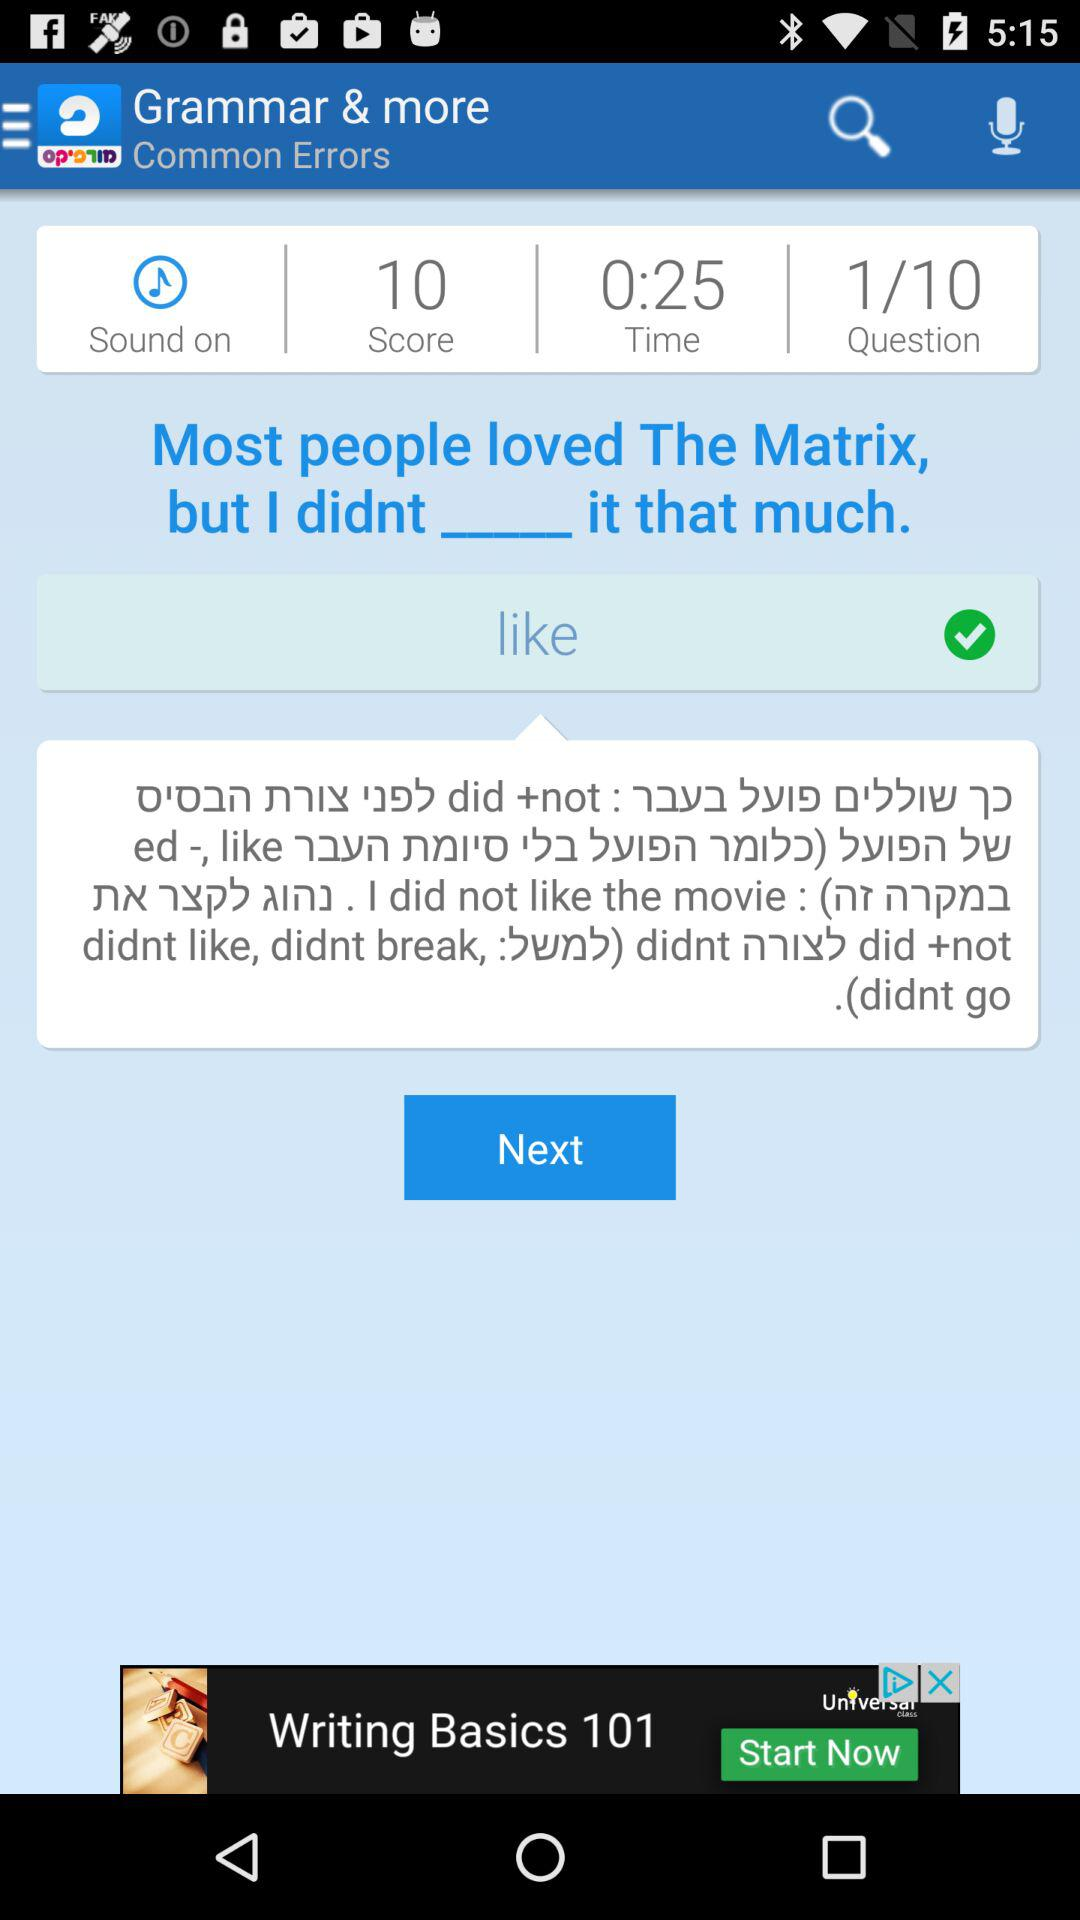How many questions are there? There are 10 questions. 